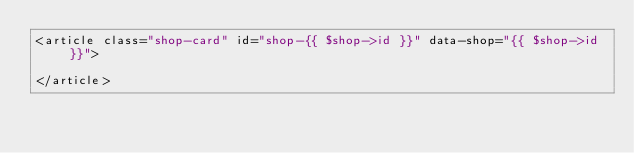<code> <loc_0><loc_0><loc_500><loc_500><_PHP_><article class="shop-card" id="shop-{{ $shop->id }}" data-shop="{{ $shop->id }}">
    
</article></code> 